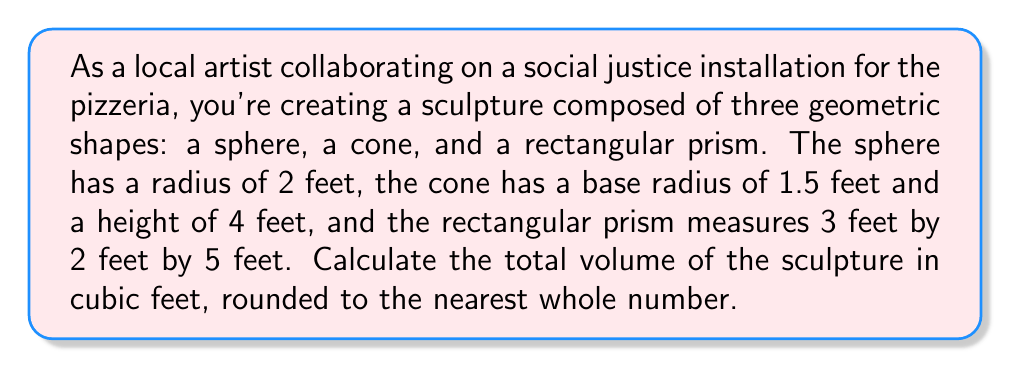Solve this math problem. To solve this problem, we need to calculate the volume of each shape and then sum them up:

1. Volume of the sphere:
   The formula for the volume of a sphere is $V_s = \frac{4}{3}\pi r^3$
   $$V_s = \frac{4}{3}\pi (2)^3 = \frac{32}{3}\pi \approx 33.51 \text{ cubic feet}$$

2. Volume of the cone:
   The formula for the volume of a cone is $V_c = \frac{1}{3}\pi r^2 h$
   $$V_c = \frac{1}{3}\pi (1.5)^2 (4) = 3\pi \approx 9.42 \text{ cubic feet}$$

3. Volume of the rectangular prism:
   The formula for the volume of a rectangular prism is $V_p = l \times w \times h$
   $$V_p = 3 \times 2 \times 5 = 30 \text{ cubic feet}$$

4. Total volume:
   Sum up the volumes of all three shapes
   $$V_{\text{total}} = V_s + V_c + V_p$$
   $$V_{\text{total}} = 33.51 + 9.42 + 30 = 72.93 \text{ cubic feet}$$

5. Rounding to the nearest whole number:
   $$V_{\text{total}} \approx 73 \text{ cubic feet}$$
Answer: 73 cubic feet 